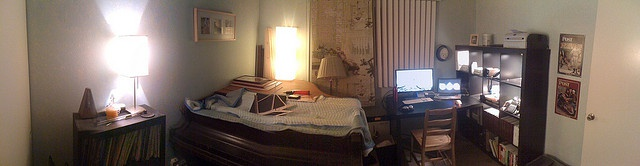Describe the objects in this image and their specific colors. I can see bed in tan, black, and gray tones, book in black, maroon, and tan tones, chair in tan, black, maroon, gray, and brown tones, tv in tan, lavender, lightblue, gray, and darkgray tones, and laptop in tan, white, gray, and darkgray tones in this image. 